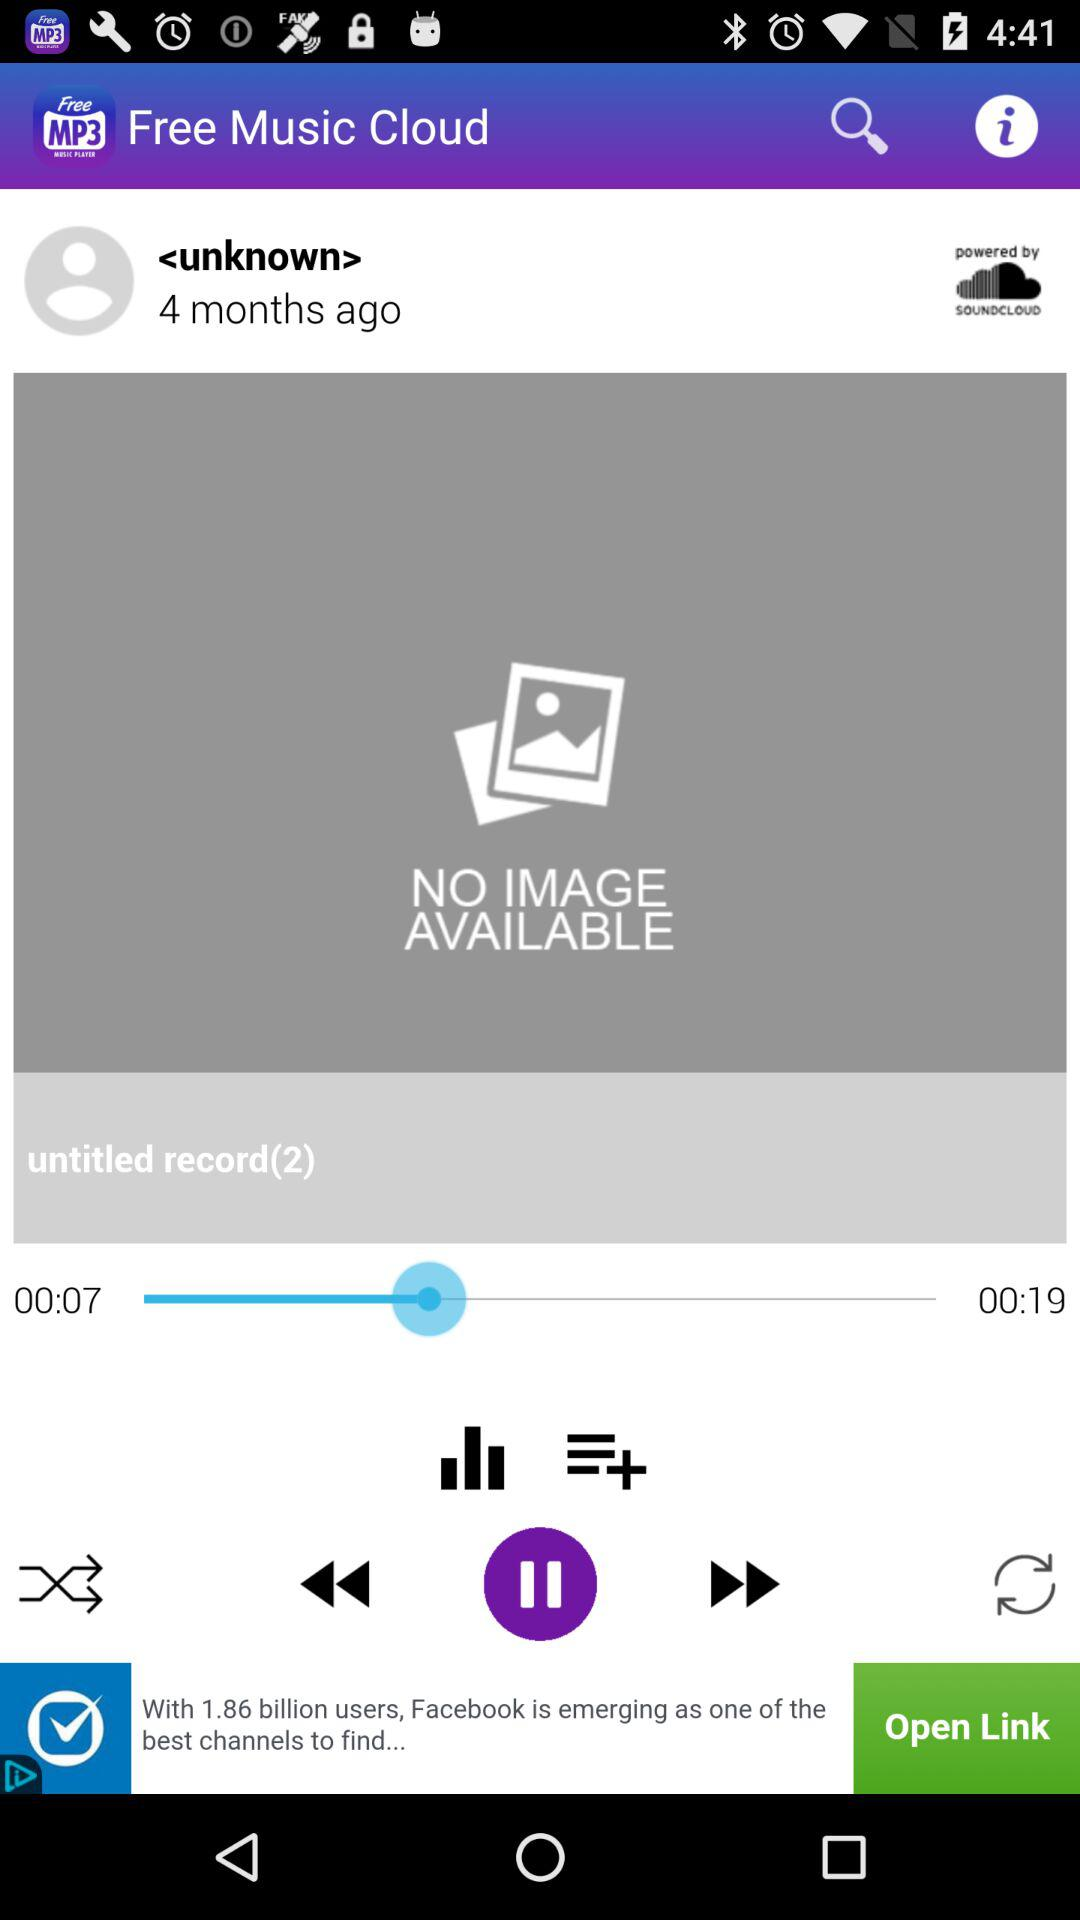What features are available in this music player application? The music player app shown in the image includes features such as play and pause button, skip to the previous and next tracks, shuffle play mode, and a repeat track option. It also displays the progress of the track that is currently being played via a progress bar. 